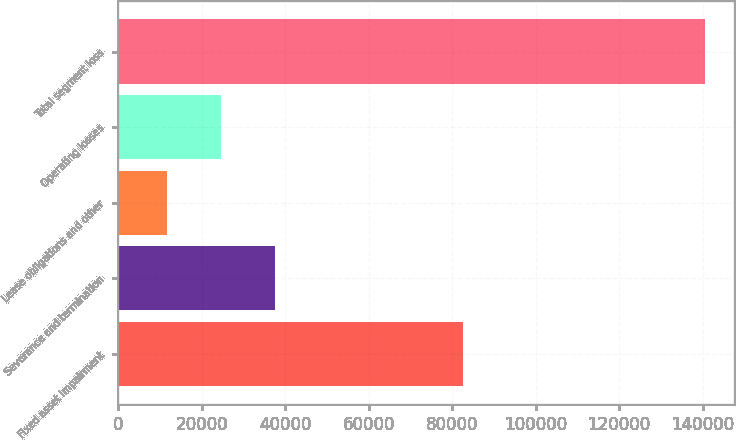Convert chart. <chart><loc_0><loc_0><loc_500><loc_500><bar_chart><fcel>Fixed asset impairment<fcel>Severance and termination<fcel>Lease obligations and other<fcel>Operating losses<fcel>Total segment loss<nl><fcel>82589<fcel>37480.2<fcel>11700<fcel>24590.1<fcel>140601<nl></chart> 